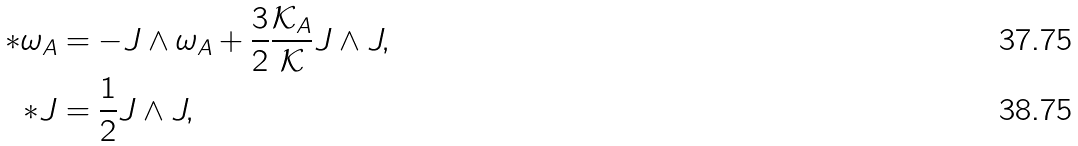Convert formula to latex. <formula><loc_0><loc_0><loc_500><loc_500>* \omega _ { A } & = - J \wedge \omega _ { A } + \frac { 3 } { 2 } \frac { \mathcal { K } _ { A } } { \mathcal { K } } J \wedge J , \\ * J & = \frac { 1 } { 2 } J \wedge J ,</formula> 